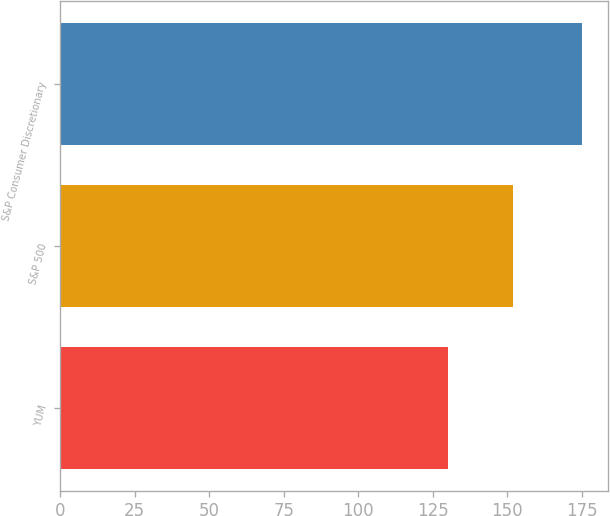Convert chart to OTSL. <chart><loc_0><loc_0><loc_500><loc_500><bar_chart><fcel>YUM<fcel>S&P 500<fcel>S&P Consumer Discretionary<nl><fcel>130<fcel>152<fcel>175<nl></chart> 